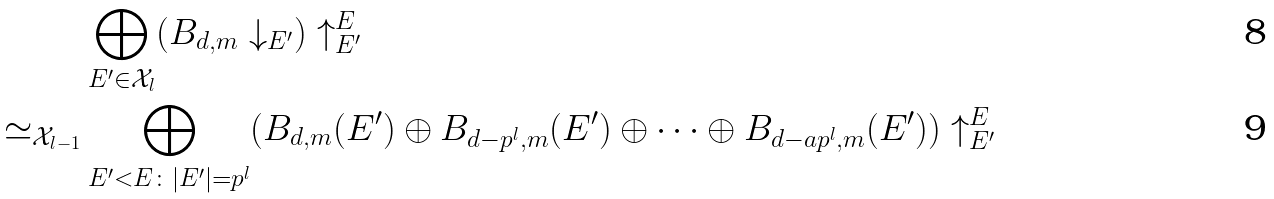<formula> <loc_0><loc_0><loc_500><loc_500>& \bigoplus _ { E ^ { \prime } \in \mathcal { X } _ { l } } ( B _ { d , m } \downarrow _ { E ^ { \prime } } ) \uparrow ^ { E } _ { E ^ { \prime } } \\ \simeq _ { \mathcal { X } _ { l - 1 } } & \bigoplus _ { E ^ { \prime } < E \colon | E ^ { \prime } | = p ^ { l } } ( B _ { d , m } ( E ^ { \prime } ) \oplus B _ { d - p ^ { l } , m } ( E ^ { \prime } ) \oplus \dots \oplus B _ { d - a p ^ { l } , m } ( E ^ { \prime } ) ) \uparrow ^ { E } _ { E ^ { \prime } }</formula> 